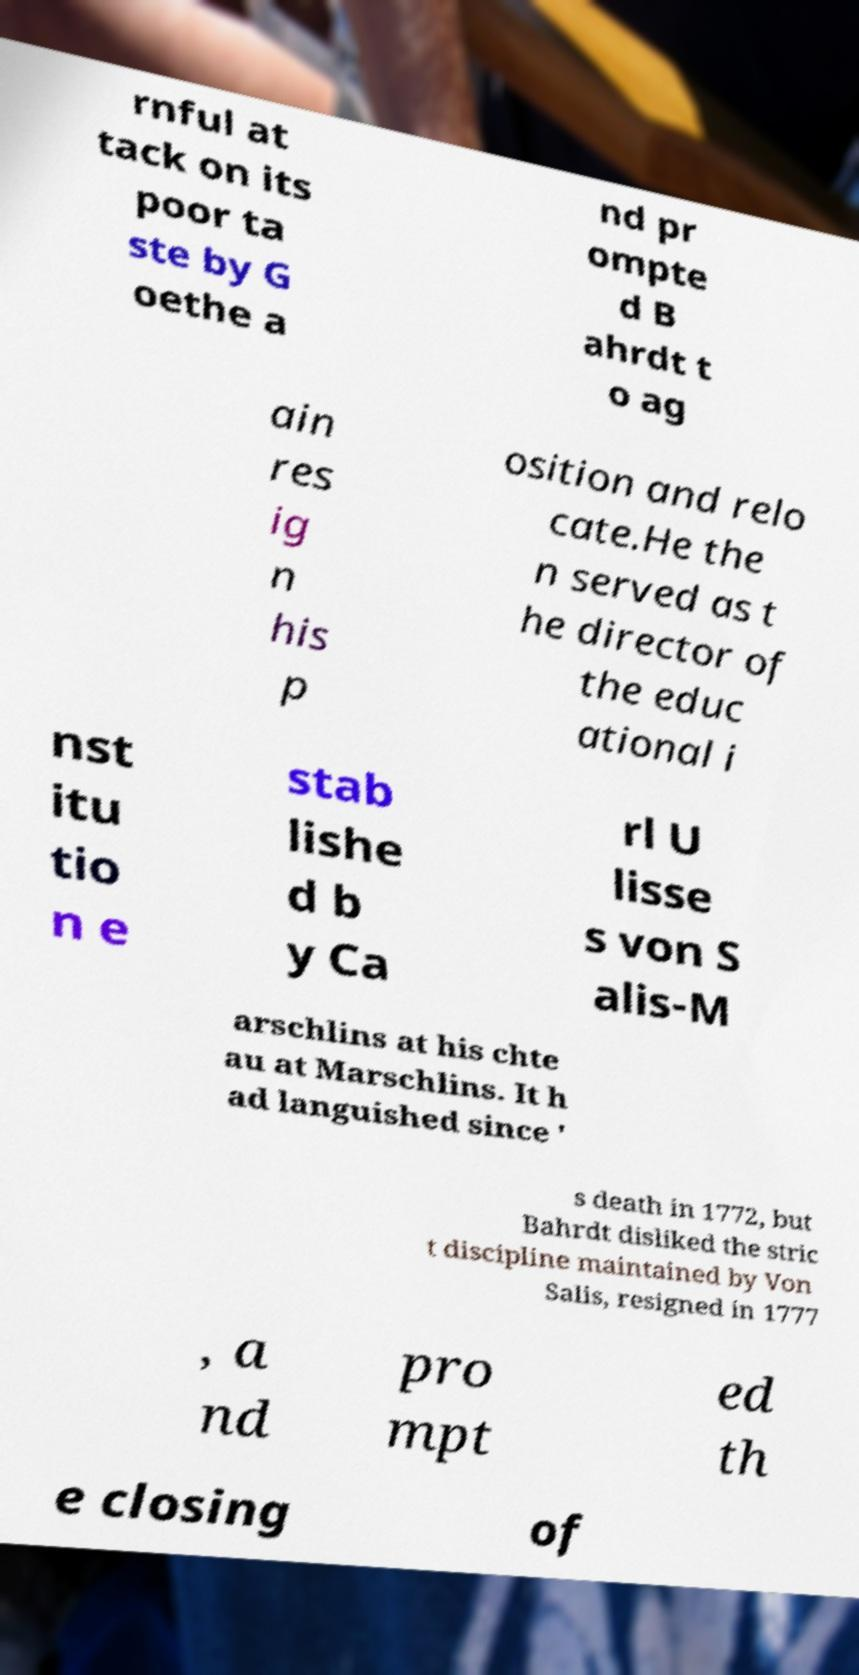Could you assist in decoding the text presented in this image and type it out clearly? rnful at tack on its poor ta ste by G oethe a nd pr ompte d B ahrdt t o ag ain res ig n his p osition and relo cate.He the n served as t he director of the educ ational i nst itu tio n e stab lishe d b y Ca rl U lisse s von S alis-M arschlins at his chte au at Marschlins. It h ad languished since ' s death in 1772, but Bahrdt disliked the stric t discipline maintained by Von Salis, resigned in 1777 , a nd pro mpt ed th e closing of 